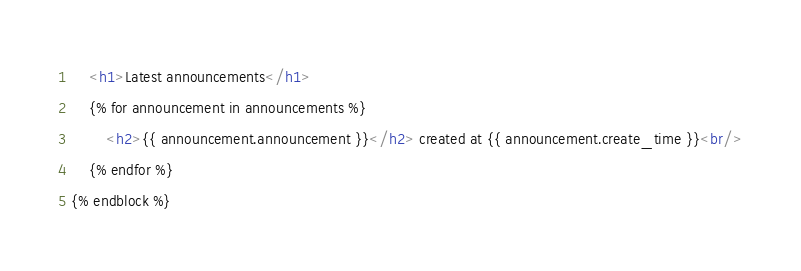<code> <loc_0><loc_0><loc_500><loc_500><_HTML_>    <h1>Latest announcements</h1>
    {% for announcement in announcements %}
        <h2>{{ announcement.announcement }}</h2> created at {{ announcement.create_time }}<br/>
    {% endfor %}
{% endblock %}</code> 